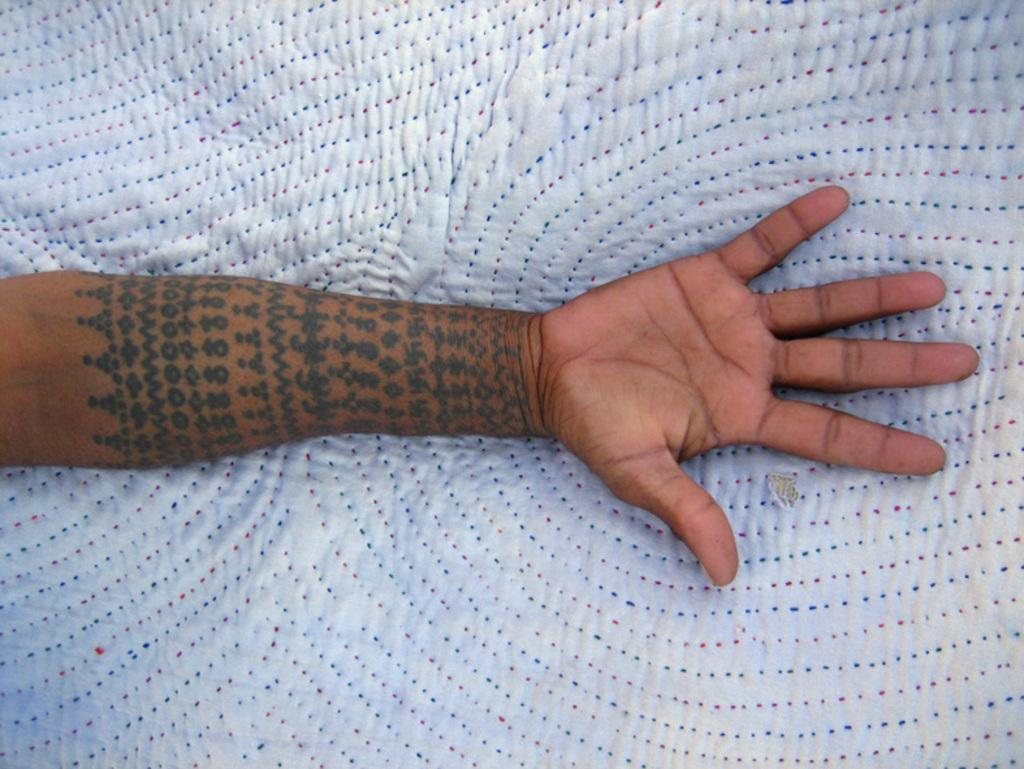What is the main subject of the image? The main subject of the image is hands on cloth. Are there any distinguishing features on the hands? Yes, there is a tattoo on one of the hands. What type of bells can be heard ringing in the image? There are no bells present in the image, and therefore no sound can be heard. 